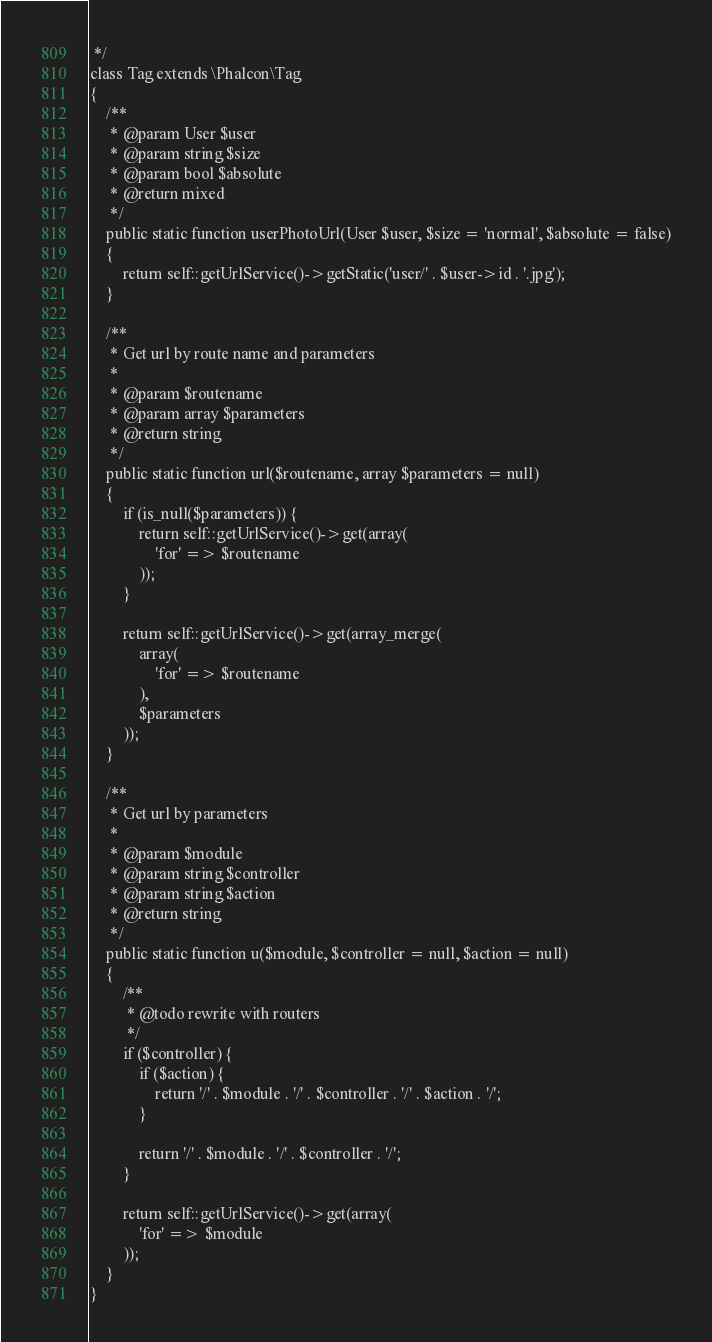Convert code to text. <code><loc_0><loc_0><loc_500><loc_500><_PHP_> */
class Tag extends \Phalcon\Tag
{
    /**
     * @param User $user
     * @param string $size
     * @param bool $absolute
     * @return mixed
     */
    public static function userPhotoUrl(User $user, $size = 'normal', $absolute = false)
    {
        return self::getUrlService()->getStatic('user/' . $user->id . '.jpg');
    }

    /**
     * Get url by route name and parameters
     *
     * @param $routename
     * @param array $parameters
     * @return string
     */
    public static function url($routename, array $parameters = null)
    {
        if (is_null($parameters)) {
            return self::getUrlService()->get(array(
                'for' => $routename
            ));
        }

        return self::getUrlService()->get(array_merge(
            array(
                'for' => $routename
            ),
            $parameters
        ));
    }

    /**
     * Get url by parameters
     *
     * @param $module
     * @param string $controller
     * @param string $action
     * @return string
     */
    public static function u($module, $controller = null, $action = null)
    {
        /**
         * @todo rewrite with routers
         */
        if ($controller) {
            if ($action) {
                return '/' . $module . '/' . $controller . '/' . $action . '/';
            }

            return '/' . $module . '/' . $controller . '/';
        }

        return self::getUrlService()->get(array(
            'for' => $module
        ));
    }
}
</code> 